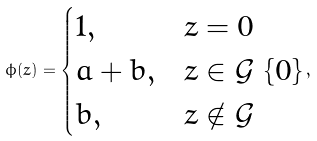Convert formula to latex. <formula><loc_0><loc_0><loc_500><loc_500>\phi ( z ) = \begin{cases} 1 , & z = 0 \\ a + b , & z \in \mathcal { G } \ \{ 0 \} \\ b , & z \notin \mathcal { G } \end{cases} ,</formula> 